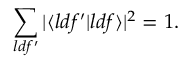<formula> <loc_0><loc_0><loc_500><loc_500>\sum _ { l d f ^ { \prime } } | \langle { l d f ^ { \prime } } | { l d f } \rangle | ^ { 2 } = 1 .</formula> 